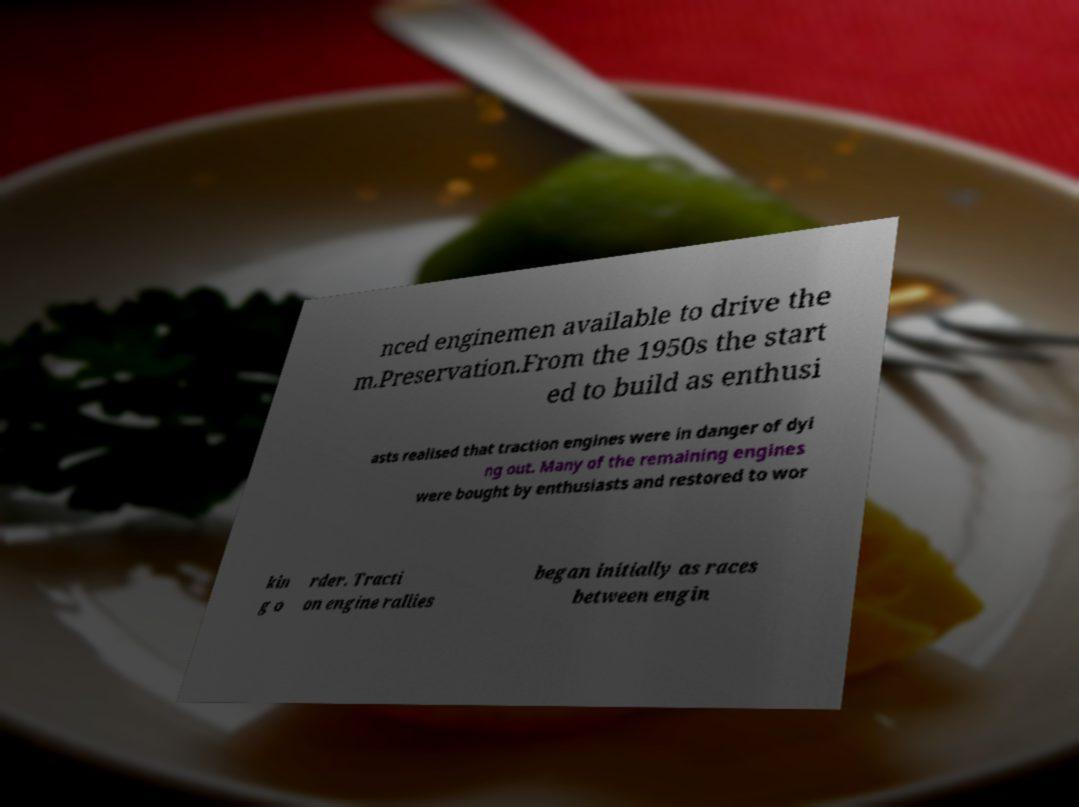Could you extract and type out the text from this image? nced enginemen available to drive the m.Preservation.From the 1950s the start ed to build as enthusi asts realised that traction engines were in danger of dyi ng out. Many of the remaining engines were bought by enthusiasts and restored to wor kin g o rder. Tracti on engine rallies began initially as races between engin 